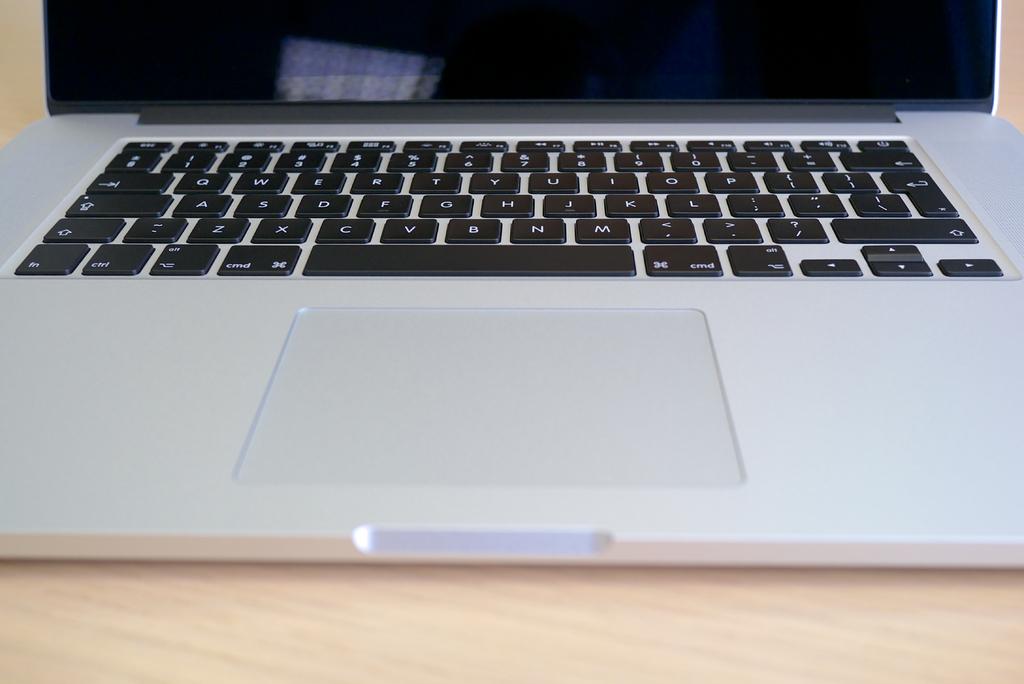What is they key to the right of s?
Your response must be concise. D. 